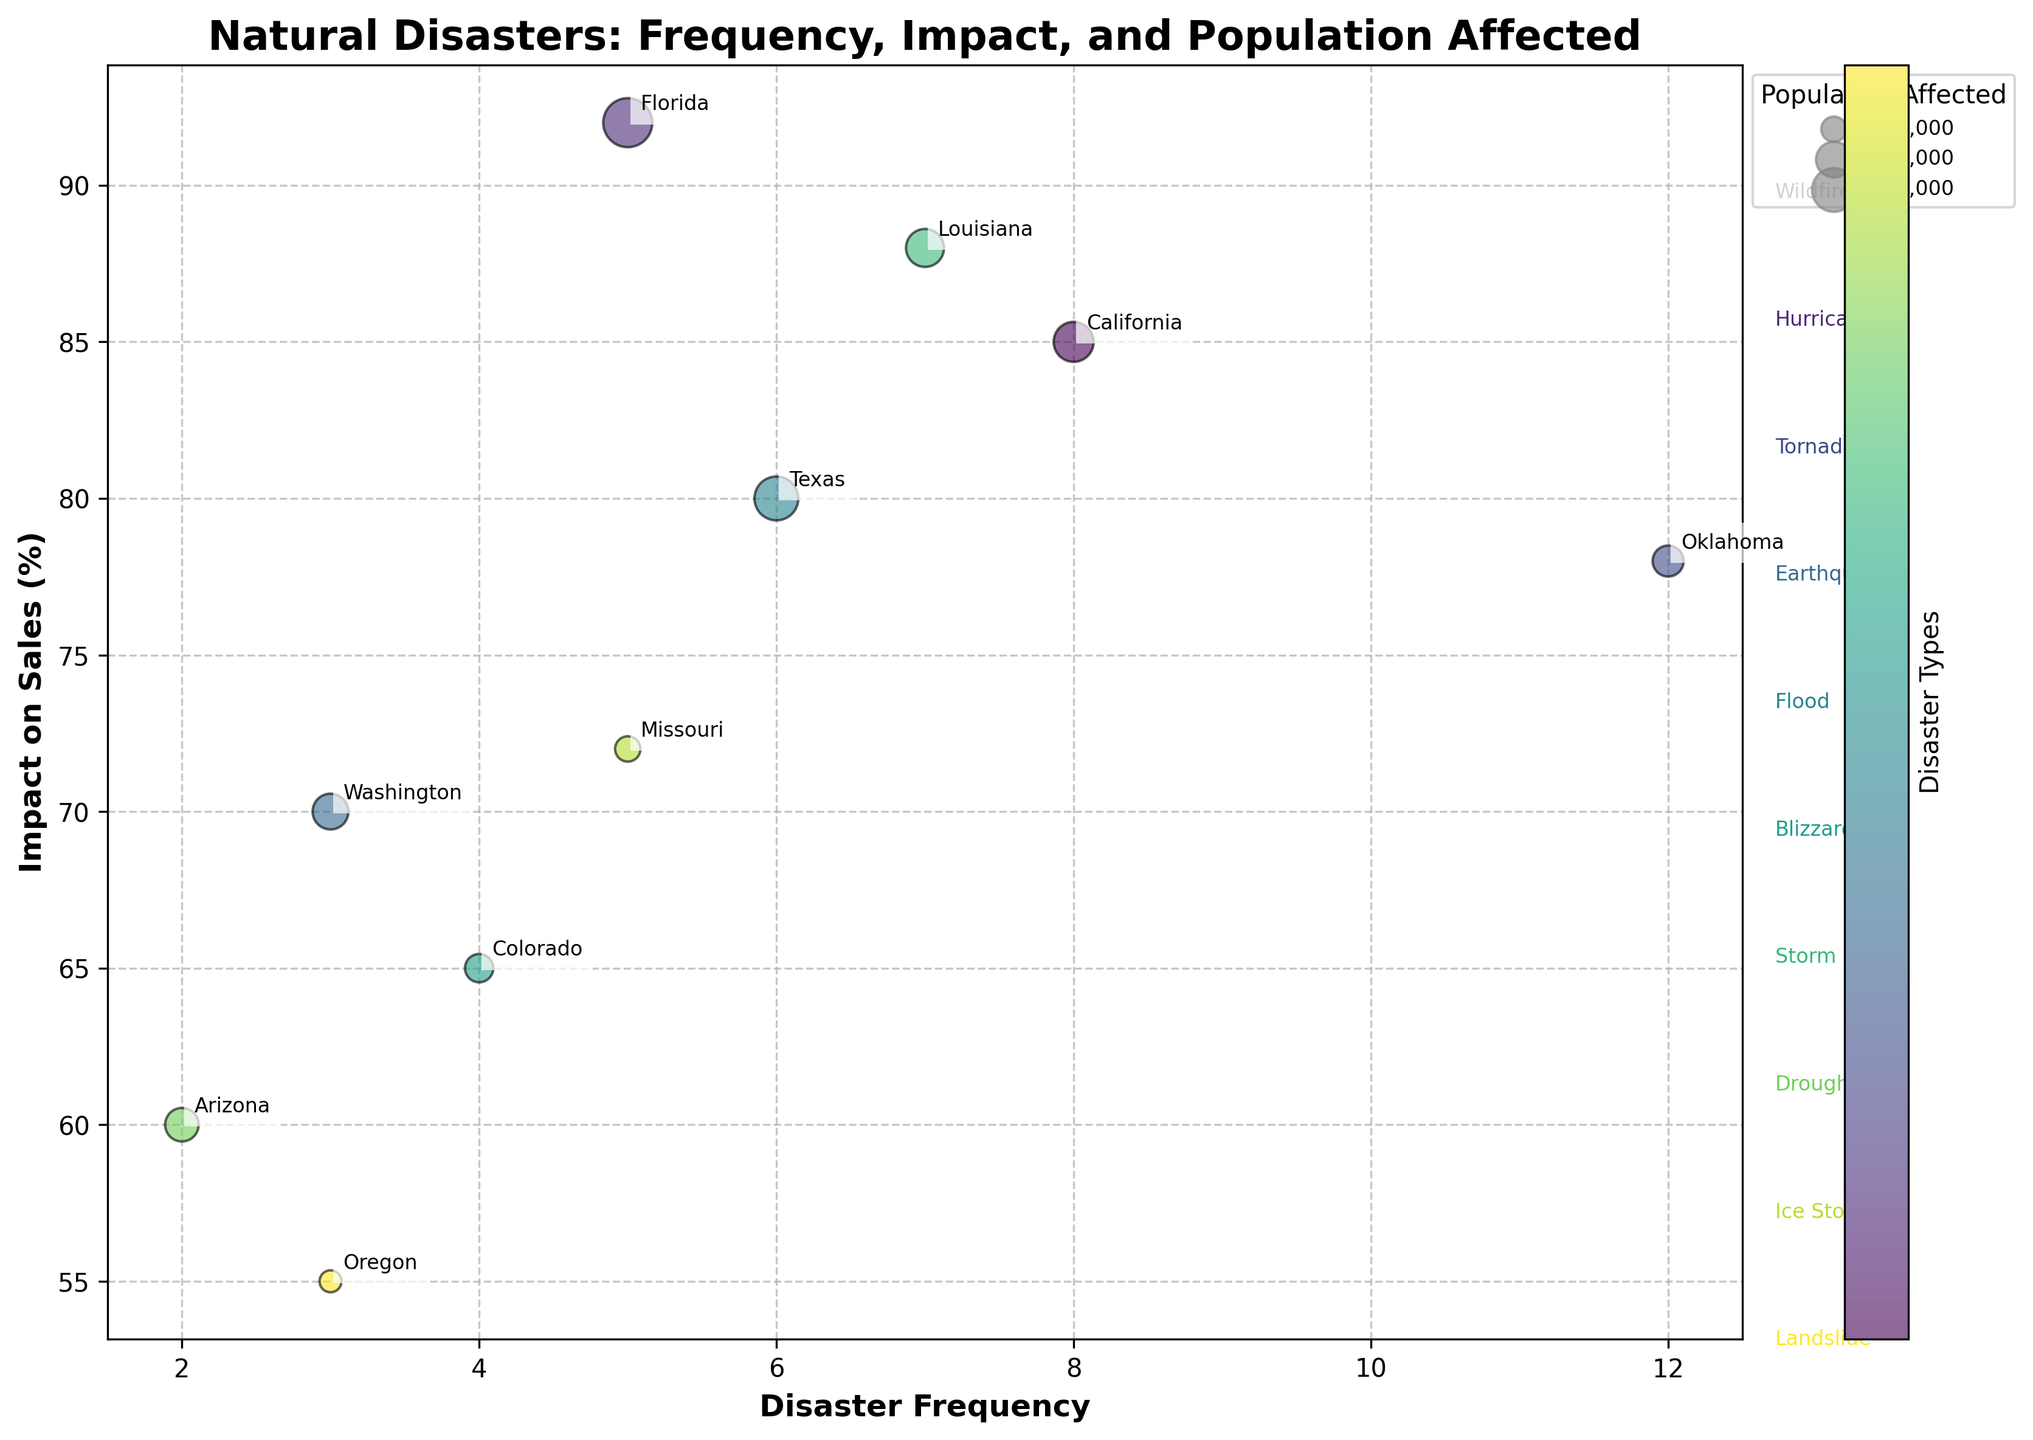What is the title of the figure? The title is located at the top of the figure, which usually summarizes what the chart is about.
Answer: Natural Disasters: Frequency, Impact, and Population Affected Which disaster type has the highest impact on sales? We look at the y-axis for "Impact on Sales (%)" and find the highest point. Then, we read the corresponding disaster type, which is annotated close to the bubble.
Answer: Hurricane How many regions have a disaster frequency of more than 5? We refer to the x-axis labeled "Disaster Frequency" and count the number of bubbles where the frequency is greater than 5.
Answer: 4 regions Compare the impact on sales between California and Louisiana. Which one has a higher impact? We look at the y-axis and find the bubbles for California and Louisiana. Then, we compare their y-coordinates.
Answer: Louisiana What is the total population affected by wildfires and earthquakes? We identify the bubbles for California (Wildfire) and Washington (Earthquake). We then sum their population affected values: 500,000 (California) + 400,000 (Washington) = 900,000.
Answer: 900,000 Which disaster type occurs most frequently? We look at the x-axis for "Disaster Frequency" and find the highest frequency value. Then, we read the corresponding disaster type, which is annotated close to the bubble.
Answer: Tornado What is the average impact on sales for disasters in Florida and Texas? We identify the bubbles for Florida and Texas, and then calculate the average of their y-values for "Impact on Sales (%)": (92 + 80) / 2 = 86.
Answer: 86 Which region has the smallest bubble? Bubbles represent the population affected, so the smallest bubble corresponds to the region with the smallest population affected. This is Missouri with 200,000 people.
Answer: Missouri What is the range of disaster frequencies in the figure? The range is the difference between the maximum and minimum values on the x-axis labeled "Disaster Frequency." The highest value is 12 (Oklahoma), and the lowest is 2 (Arizona), so 12 - 2 = 10.
Answer: 10 